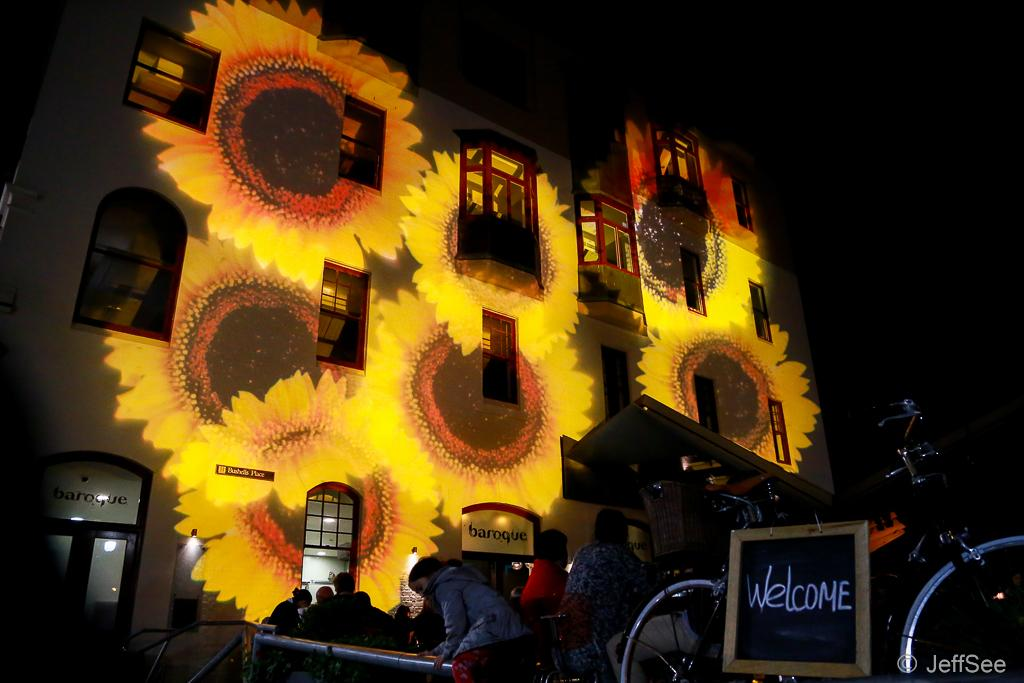What is the main structure in the image? There is a building in the image. What is unique about the lighting in the image? There are flower-like lights focusing on the building. Are there any people present in the image? Yes, there are people standing in front of the building. What type of thread is being used to play the game in the image? There is no game or thread present in the image. What material is the leather used for in the image? There is no leather present in the image. 